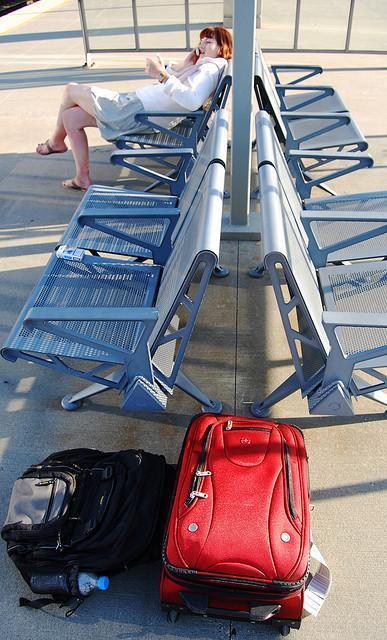How many backpacks?
Give a very brief answer. 1. How many suitcases are in the photo?
Give a very brief answer. 1. How many benches are there?
Give a very brief answer. 7. 